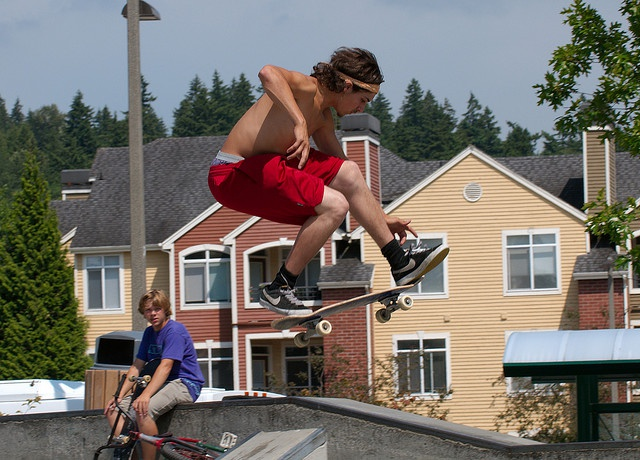Describe the objects in this image and their specific colors. I can see people in darkgray, maroon, black, and brown tones, people in darkgray, black, brown, gray, and blue tones, bicycle in darkgray, black, gray, and maroon tones, and skateboard in darkgray, black, and gray tones in this image. 